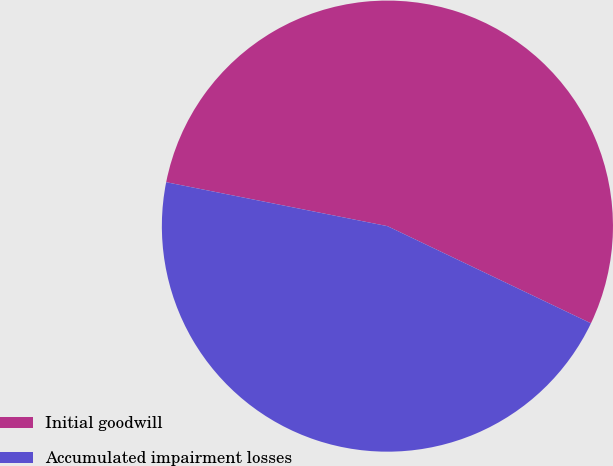<chart> <loc_0><loc_0><loc_500><loc_500><pie_chart><fcel>Initial goodwill<fcel>Accumulated impairment losses<nl><fcel>53.97%<fcel>46.03%<nl></chart> 